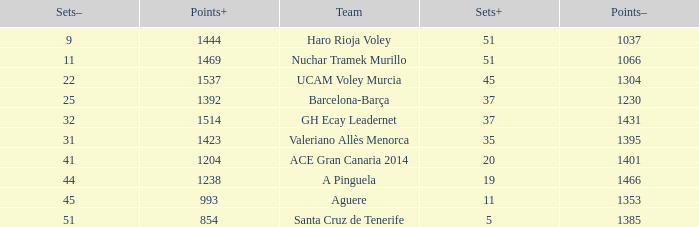What is the highest Sets+ number for Valeriano Allès Menorca when the Sets- number was larger than 31? None. 